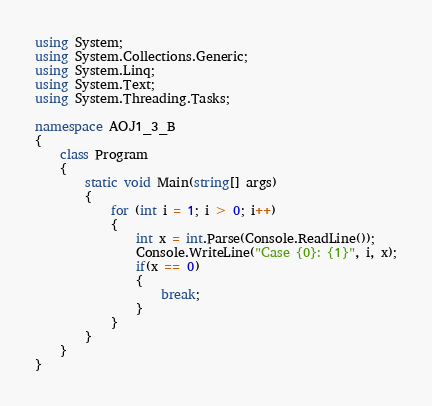Convert code to text. <code><loc_0><loc_0><loc_500><loc_500><_C#_>using System;
using System.Collections.Generic;
using System.Linq;
using System.Text;
using System.Threading.Tasks;

namespace AOJ1_3_B
{
    class Program
    {
        static void Main(string[] args)
        {
            for (int i = 1; i > 0; i++) 
            {
                int x = int.Parse(Console.ReadLine());
                Console.WriteLine("Case {0}: {1}", i, x);
                if(x == 0)
                {
                    break;
                }
            }
        }
    }
}

</code> 